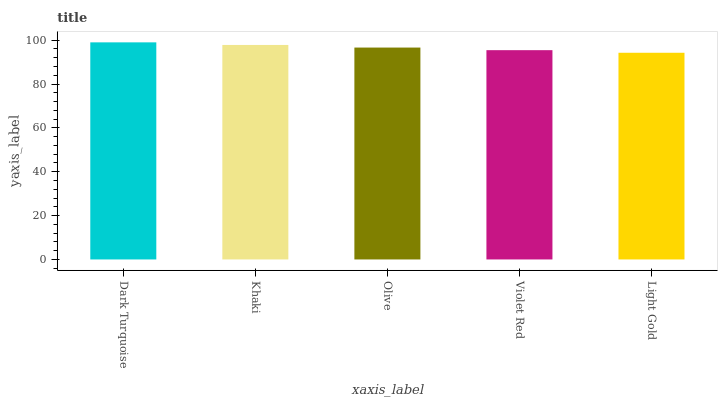Is Light Gold the minimum?
Answer yes or no. Yes. Is Dark Turquoise the maximum?
Answer yes or no. Yes. Is Khaki the minimum?
Answer yes or no. No. Is Khaki the maximum?
Answer yes or no. No. Is Dark Turquoise greater than Khaki?
Answer yes or no. Yes. Is Khaki less than Dark Turquoise?
Answer yes or no. Yes. Is Khaki greater than Dark Turquoise?
Answer yes or no. No. Is Dark Turquoise less than Khaki?
Answer yes or no. No. Is Olive the high median?
Answer yes or no. Yes. Is Olive the low median?
Answer yes or no. Yes. Is Dark Turquoise the high median?
Answer yes or no. No. Is Violet Red the low median?
Answer yes or no. No. 